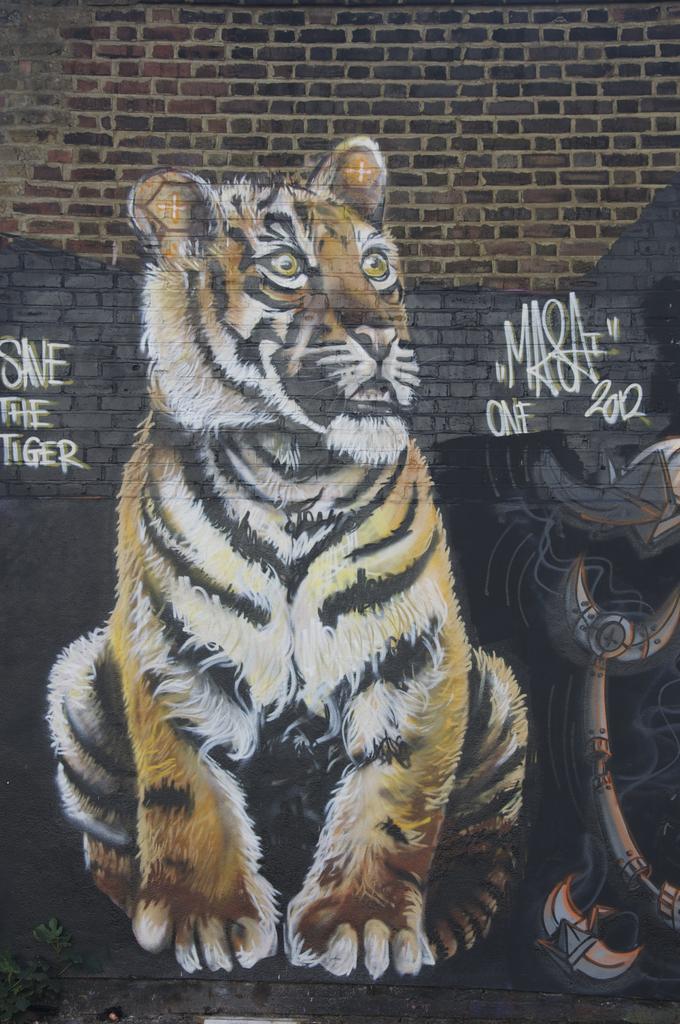Can you describe this image briefly? This is the picture of a wall. In this image there is a painting of a tiger and object and there is a text on the wall. In the bottom left there is a plant. 